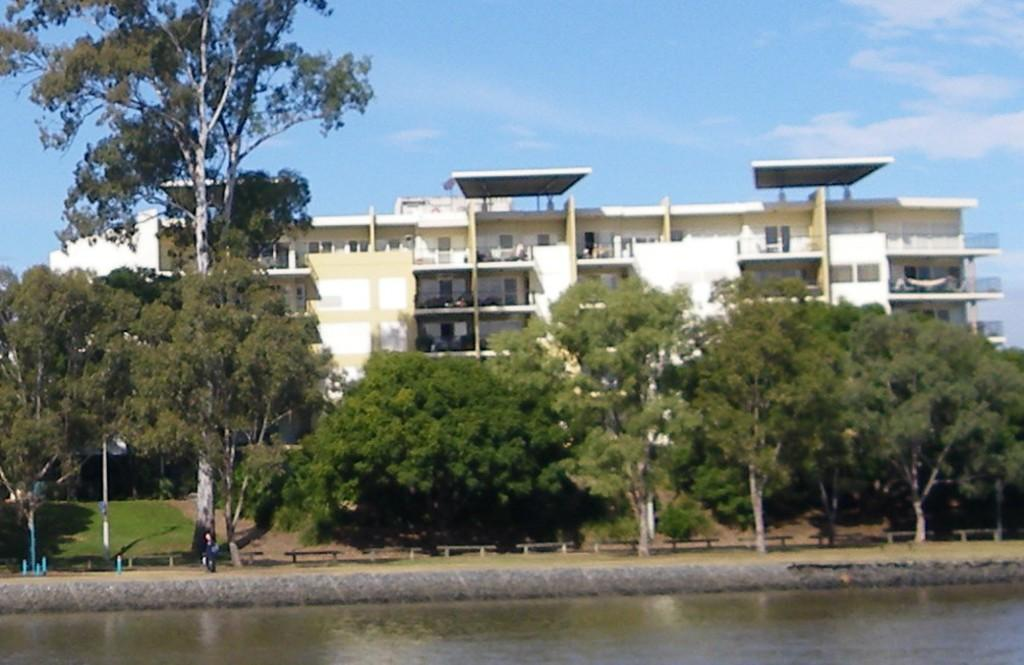What is present in the image that represents a natural resource? There is water in the image. Can you describe the person's location in relation to the water? There is a person beside the water. What type of furniture is present on the ground in the image? There are benches on the ground. What can be seen in the background of the image? There is a building, trees, and the sky visible in the background of the image. What type of canvas is being used by the person in the image? There is no canvas present in the image; the person is simply standing beside the water. 